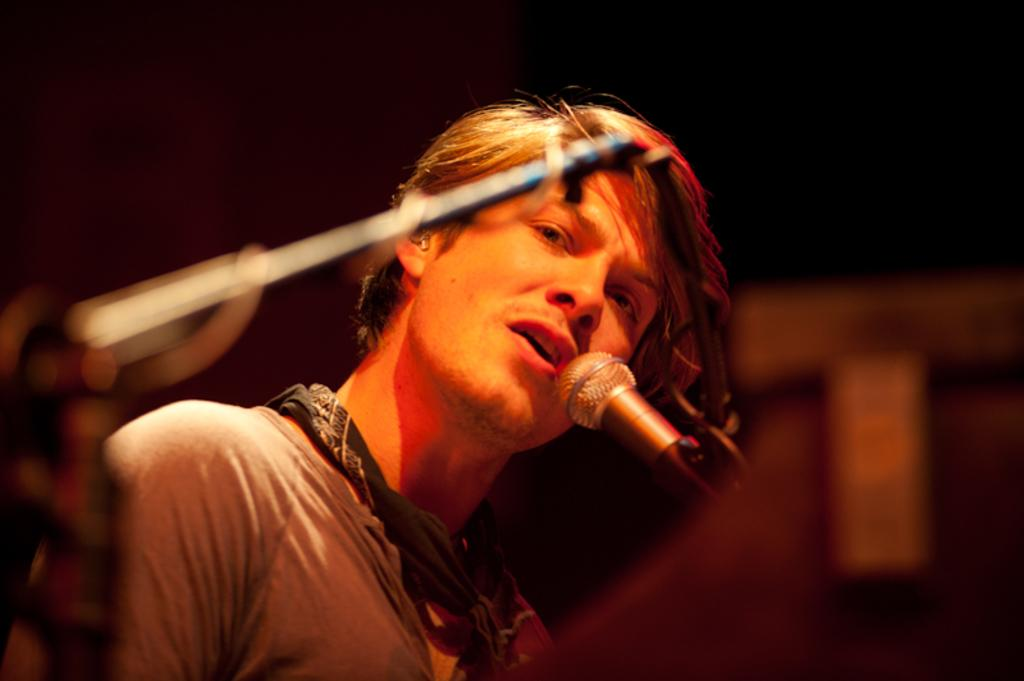Who is present in the image? There is a man in the image. What object can be seen in the image? There is a mic in the image. Can you describe the objects in the image? There are objects in the image, but their specific details are not clear due to the blurry background. What can be inferred about the image's focus? The background of the image is blurry, suggesting that the focus is on the man and the mic. What type of crown is the man wearing in the image? There is no crown present in the image; the man is not wearing any headgear. 